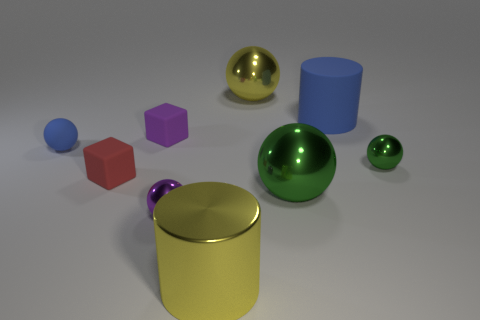Subtract all yellow spheres. How many spheres are left? 4 Subtract all small blue matte spheres. How many spheres are left? 4 Subtract 1 spheres. How many spheres are left? 4 Subtract all red spheres. Subtract all brown cylinders. How many spheres are left? 5 Add 1 big cylinders. How many objects exist? 10 Subtract all spheres. How many objects are left? 4 Subtract all big blue things. Subtract all purple spheres. How many objects are left? 7 Add 5 yellow metallic cylinders. How many yellow metallic cylinders are left? 6 Add 8 red rubber balls. How many red rubber balls exist? 8 Subtract 0 yellow cubes. How many objects are left? 9 